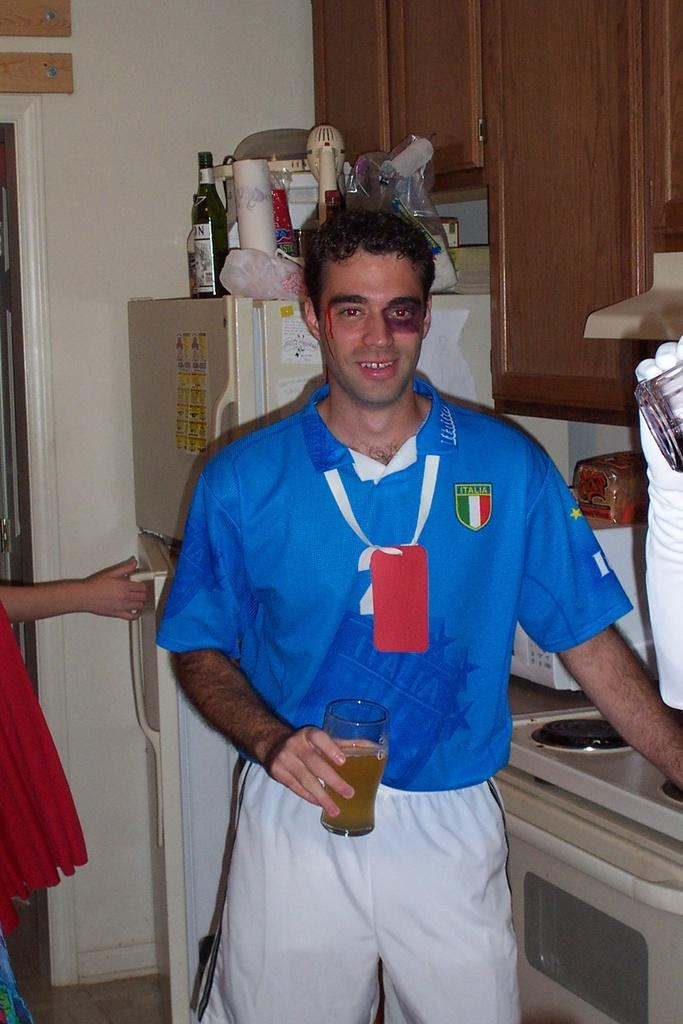<image>
Share a concise interpretation of the image provided. a man in an ITALIA jersey sports a black eye and fake blood 